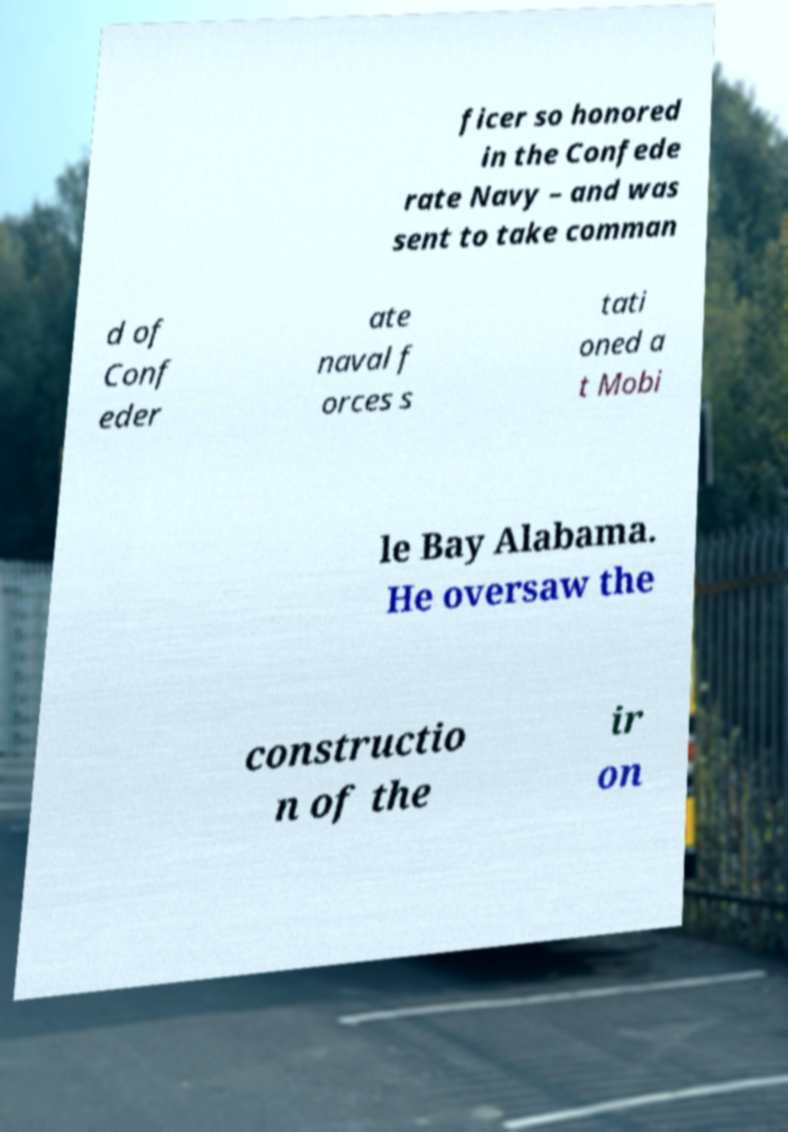For documentation purposes, I need the text within this image transcribed. Could you provide that? ficer so honored in the Confede rate Navy – and was sent to take comman d of Conf eder ate naval f orces s tati oned a t Mobi le Bay Alabama. He oversaw the constructio n of the ir on 